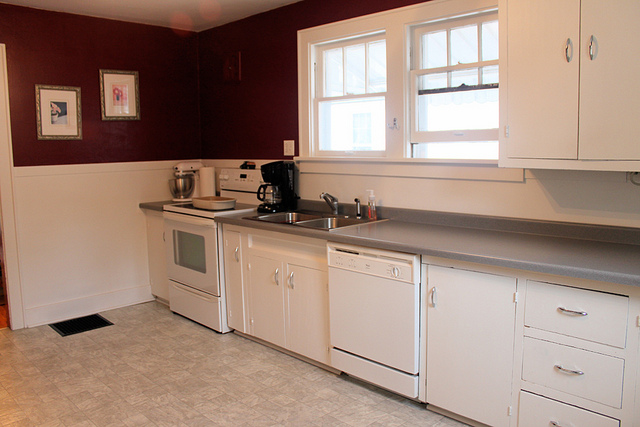How would you describe the flooring in the kitchen? The flooring in the kitchen appears to be made of vinyl or linoleum with a pattern resembling tiles, providing a practical and easy-to-clean surface. 